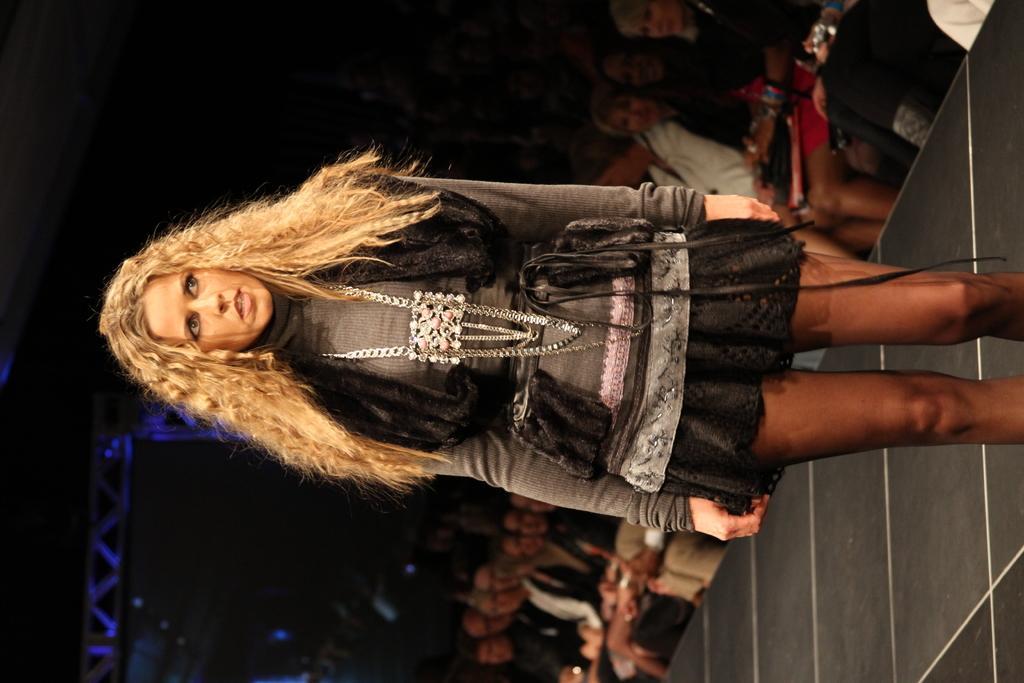In one or two sentences, can you explain what this image depicts? In this image we can see a person standing on the floor. In the background there are iron grills and person sitting on the chairs. 